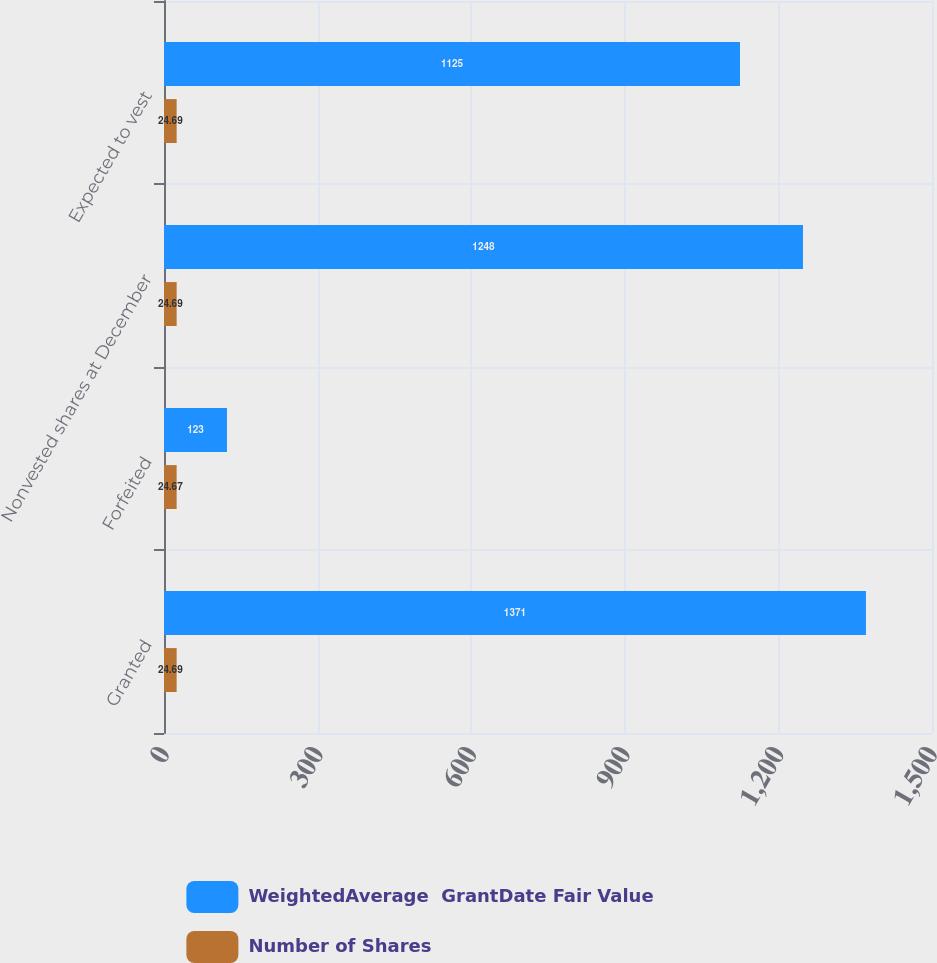Convert chart to OTSL. <chart><loc_0><loc_0><loc_500><loc_500><stacked_bar_chart><ecel><fcel>Granted<fcel>Forfeited<fcel>Nonvested shares at December<fcel>Expected to vest<nl><fcel>WeightedAverage  GrantDate Fair Value<fcel>1371<fcel>123<fcel>1248<fcel>1125<nl><fcel>Number of Shares<fcel>24.69<fcel>24.67<fcel>24.69<fcel>24.69<nl></chart> 